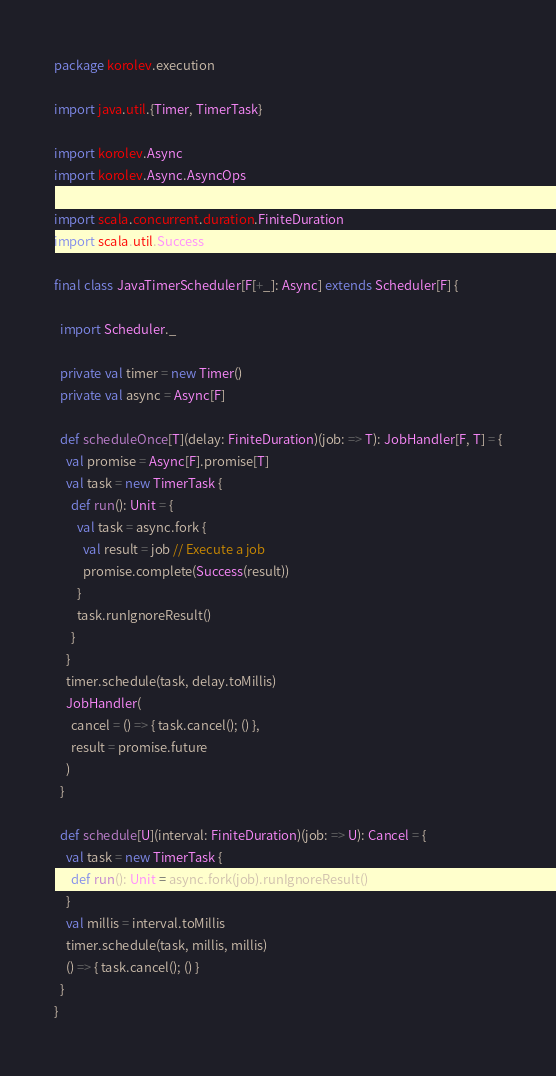Convert code to text. <code><loc_0><loc_0><loc_500><loc_500><_Scala_>package korolev.execution

import java.util.{Timer, TimerTask}

import korolev.Async
import korolev.Async.AsyncOps

import scala.concurrent.duration.FiniteDuration
import scala.util.Success

final class JavaTimerScheduler[F[+_]: Async] extends Scheduler[F] {

  import Scheduler._

  private val timer = new Timer()
  private val async = Async[F]

  def scheduleOnce[T](delay: FiniteDuration)(job: => T): JobHandler[F, T] = {
    val promise = Async[F].promise[T]
    val task = new TimerTask {
      def run(): Unit = {
        val task = async.fork {
          val result = job // Execute a job
          promise.complete(Success(result))
        }
        task.runIgnoreResult()
      }
    }
    timer.schedule(task, delay.toMillis)
    JobHandler(
      cancel = () => { task.cancel(); () },
      result = promise.future
    )
  }

  def schedule[U](interval: FiniteDuration)(job: => U): Cancel = {
    val task = new TimerTask {
      def run(): Unit = async.fork(job).runIgnoreResult()
    }
    val millis = interval.toMillis
    timer.schedule(task, millis, millis)
    () => { task.cancel(); () }
  }
}
</code> 